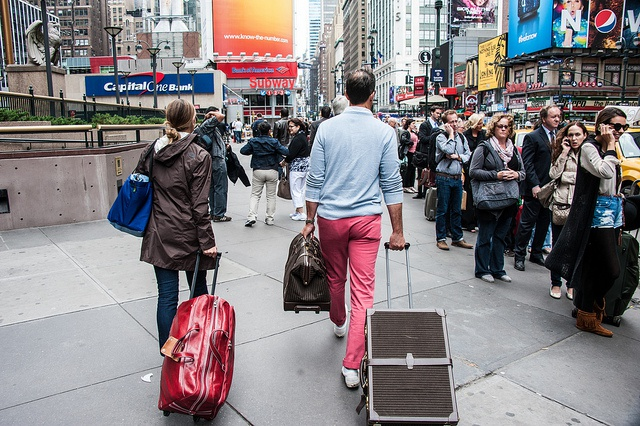Describe the objects in this image and their specific colors. I can see people in black, lightgray, maroon, lightblue, and darkgray tones, people in black, gray, and lightgray tones, people in black, lightgray, darkgray, and gray tones, suitcase in black, gray, lightgray, and darkgray tones, and suitcase in black, maroon, brown, and lightpink tones in this image. 